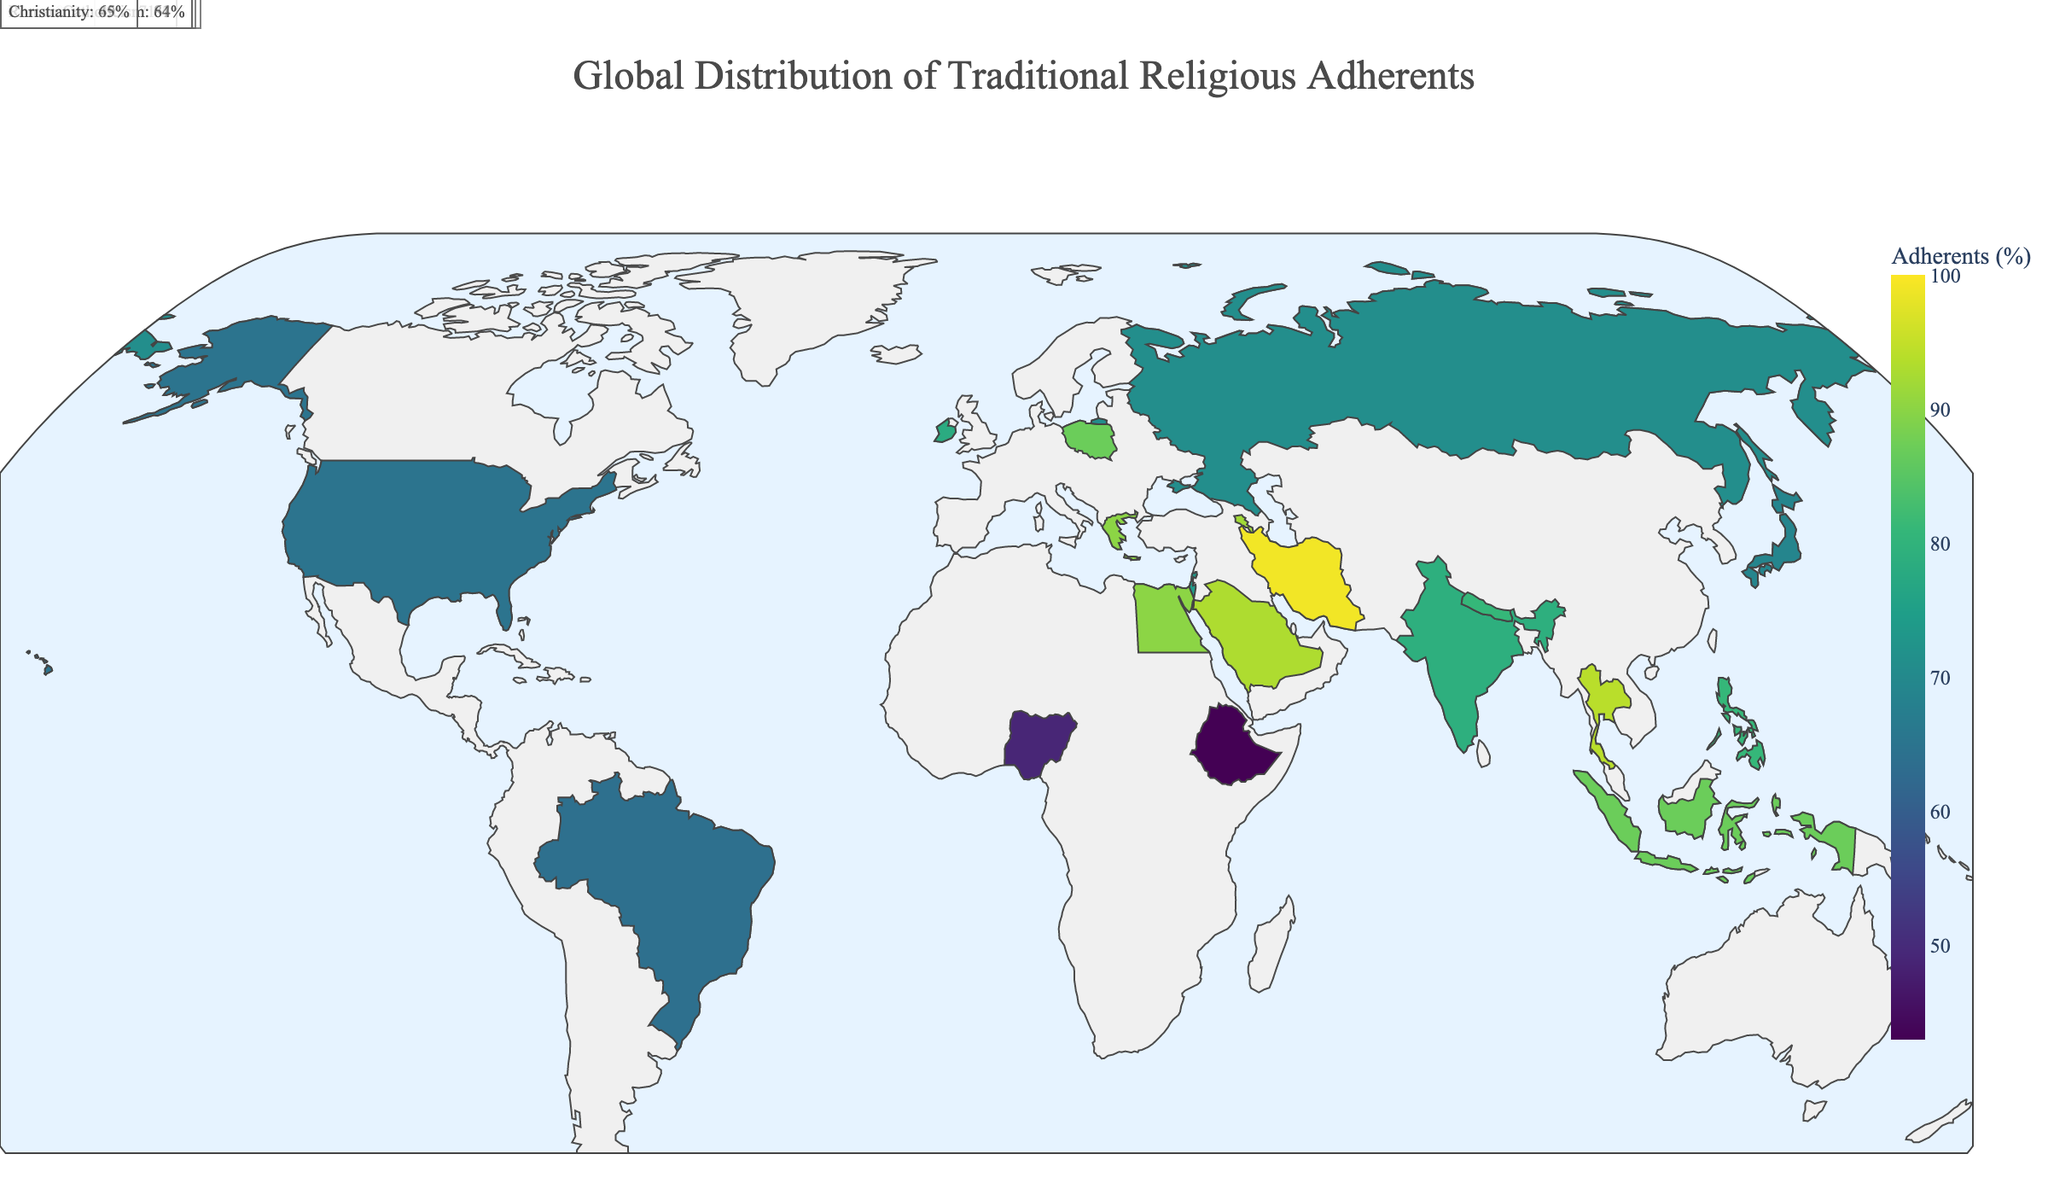What is the title of the plot? The title of the plot is situated at the top of the figure and includes descriptive text to indicate what is being visualized.
Answer: Global Distribution of Traditional Religious Adherents How many countries show a majority religion adherence percentage greater than 90%? To determine this, we look for countries where the percentage of adherents is greater than 90% and count them. Specifically, Vatican City, Saudi Arabia, Iran, Thailand, and Armenia have adherence percentages above 90%.
Answer: 5 Which country has the highest percentage of Roman Catholicism adherents? We identify countries with Roman Catholicism as the major religion and compare their percentages. Vatican City has 100% adherence, which is the highest.
Answer: Vatican City Among the countries listed, which ones have Islam as the predominant religion? To find this, we look for countries where Islam is the primary religion. The countries are Saudi Arabia, Iran, Egypt, and Indonesia.
Answer: Saudi Arabia, Iran, Egypt, Indonesia Compare the adherence percentage of Roman Catholicism in Brazil and the Philippines. Which has a higher percentage? We identify both Brazil and the Philippines in the data and compare their percentages. The Philippines has 81%, while Brazil has 64%, meaning Philippines has a higher percentage.
Answer: Philippines What is the average percentage of traditional religious adherents among all countries listed? To compute this, sum the percentages for all listed countries and divide by the number of countries. The total percentage sum is 1606, and there are 20 countries, so the average is: 1606 / 20 = 80.3%.
Answer: 80.3% Which country has the lowest percentage of traditional religious adherents and what is the percentage? By scanning through the list, we see that Ethiopia has the lowest percentage of traditional religious adherents at 43%.
Answer: Ethiopia, 43% How does the percentage of Hinduism adherents in Nepal compare with that in India? By comparing the figures for Nepal and India, we see that Nepal has 81% adherence whereas India has 79%. Nepal's adherence percentage is higher.
Answer: Nepal Can you determine the dominant religion in the United States based on the plot? By locating the United States on the plot and observing the label, it shows that Christianity, with 65%, is the dominant religion.
Answer: Christianity 